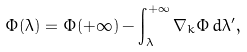Convert formula to latex. <formula><loc_0><loc_0><loc_500><loc_500>\Phi ( \lambda ) = \Phi ( + \infty ) - \int ^ { + \infty } _ { \lambda } \nabla _ { k } \Phi \, d \lambda ^ { \prime } ,</formula> 